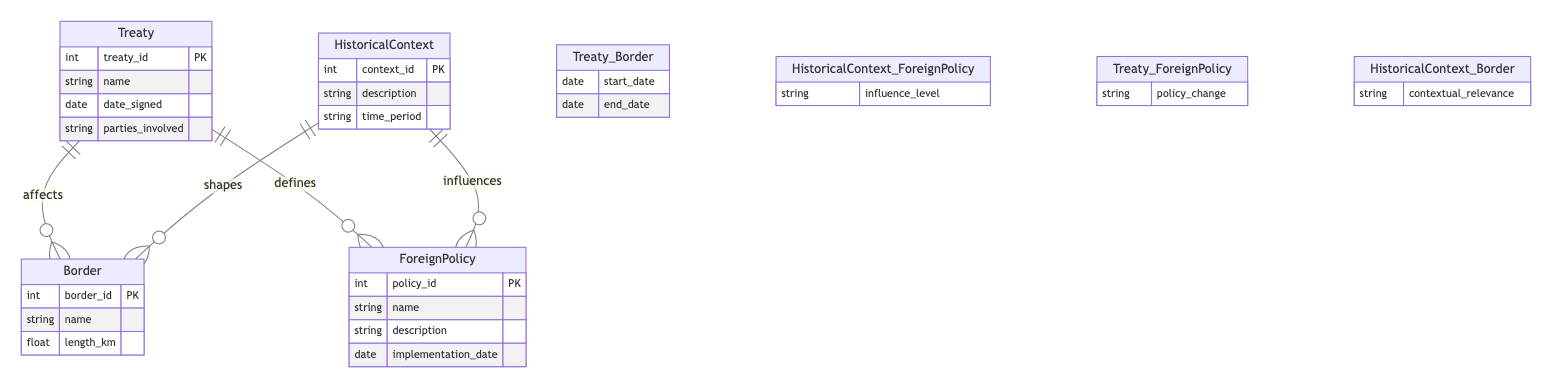What entities are present in the diagram? The entities in the diagram are Treaty, Border, HistoricalContext, and ForeignPolicy, which are all listed at the beginning of the entity specification section.
Answer: Treaty, Border, HistoricalContext, ForeignPolicy How many relationships define the entity Treaty? The diagram shows that there are two relationships defining the entity Treaty: it defines ForeignPolicy and affects Border. Thus, there are two relationships connected to Treaty.
Answer: 2 What attribute represents the length of a Border? The attribute representing the length of a Border is "length_km," which is specified under the Border entity attributes.
Answer: length_km Which entity influences ForeignPolicy? The entity that influences ForeignPolicy is HistoricalContext, as indicated by the relationship that connects these two in the diagram.
Answer: HistoricalContext What is the type of relationship between Treaty and ForeignPolicy? The type of relationship between Treaty and ForeignPolicy is defined, as per the relationships listed in the diagram.
Answer: defines Explain the significance of the "influence_level" attribute in relation to HistoricalContext and ForeignPolicy. The "influence_level" attribute indicates how strongly a particular HistoricalContext affects the ForeignPolicy. This relationship demonstrates the impact of historical backgrounds on current policies.
Answer: influence_level What does the attribute "policy_change" indicate in the diagram? The "policy_change" attribute indicates the specific alterations to ForeignPolicy that result from a Treaty. It signifies how treaties can reshape foreign policies over time.
Answer: policy_change How many entities are affected by the Treaty? The Treaty affects two entities: Border and ForeignPolicy, which are both linked by specific relationships indicating this influence.
Answer: 2 What type of relationship shapes Borders according to HistoricalContext? The relationship that shapes Borders according to HistoricalContext is characterized as shapes, which indicates the influence of historical factors on the definition of borders.
Answer: shapes 